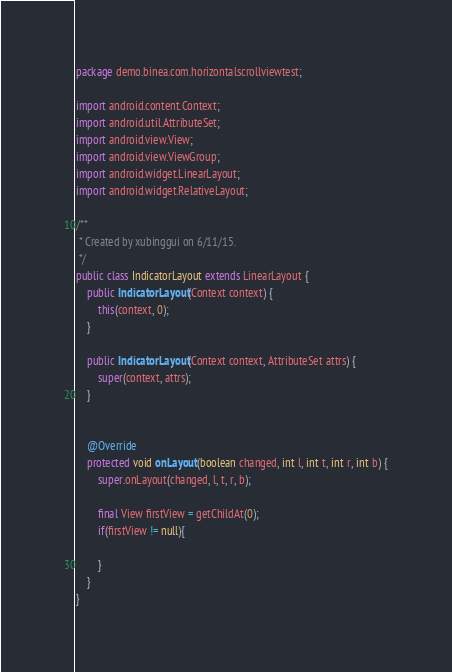<code> <loc_0><loc_0><loc_500><loc_500><_Java_>package demo.binea.com.horizontalscrollviewtest;

import android.content.Context;
import android.util.AttributeSet;
import android.view.View;
import android.view.ViewGroup;
import android.widget.LinearLayout;
import android.widget.RelativeLayout;

/**
 * Created by xubinggui on 6/11/15.
 */
public class IndicatorLayout extends LinearLayout {
	public IndicatorLayout(Context context) {
		this(context, 0);
	}

	public IndicatorLayout(Context context, AttributeSet attrs) {
		super(context, attrs);
	}


	@Override
	protected void onLayout(boolean changed, int l, int t, int r, int b) {
		super.onLayout(changed, l, t, r, b);

		final View firstView = getChildAt(0);
		if(firstView != null){

		}
	}
}
</code> 